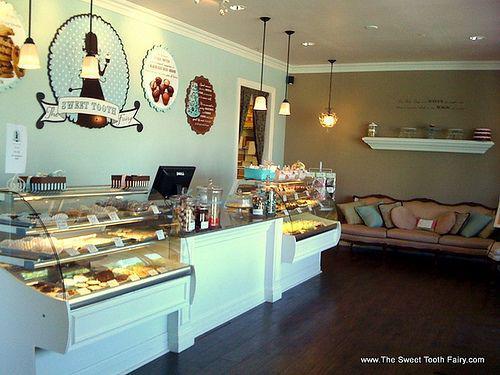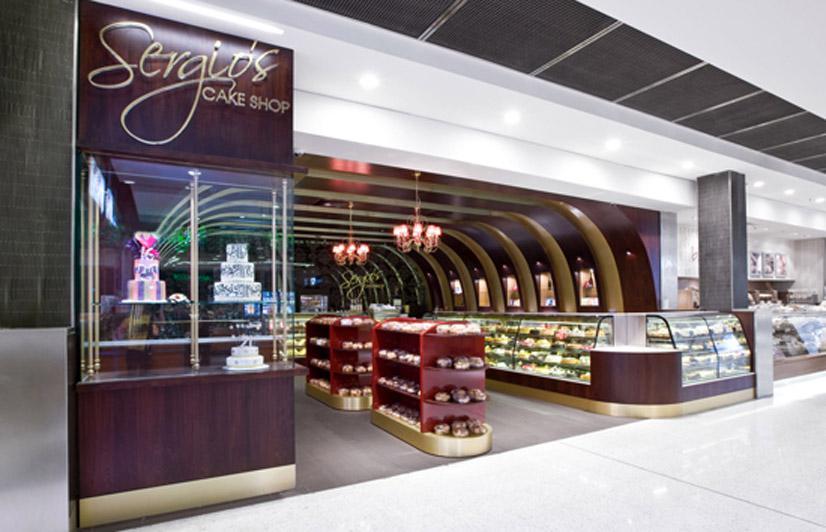The first image is the image on the left, the second image is the image on the right. Considering the images on both sides, is "Wooden tables and chairs for patrons to sit and eat are shown in one image." valid? Answer yes or no. No. The first image is the image on the left, the second image is the image on the right. Assess this claim about the two images: "One of the places has a wooden floor.". Correct or not? Answer yes or no. Yes. 